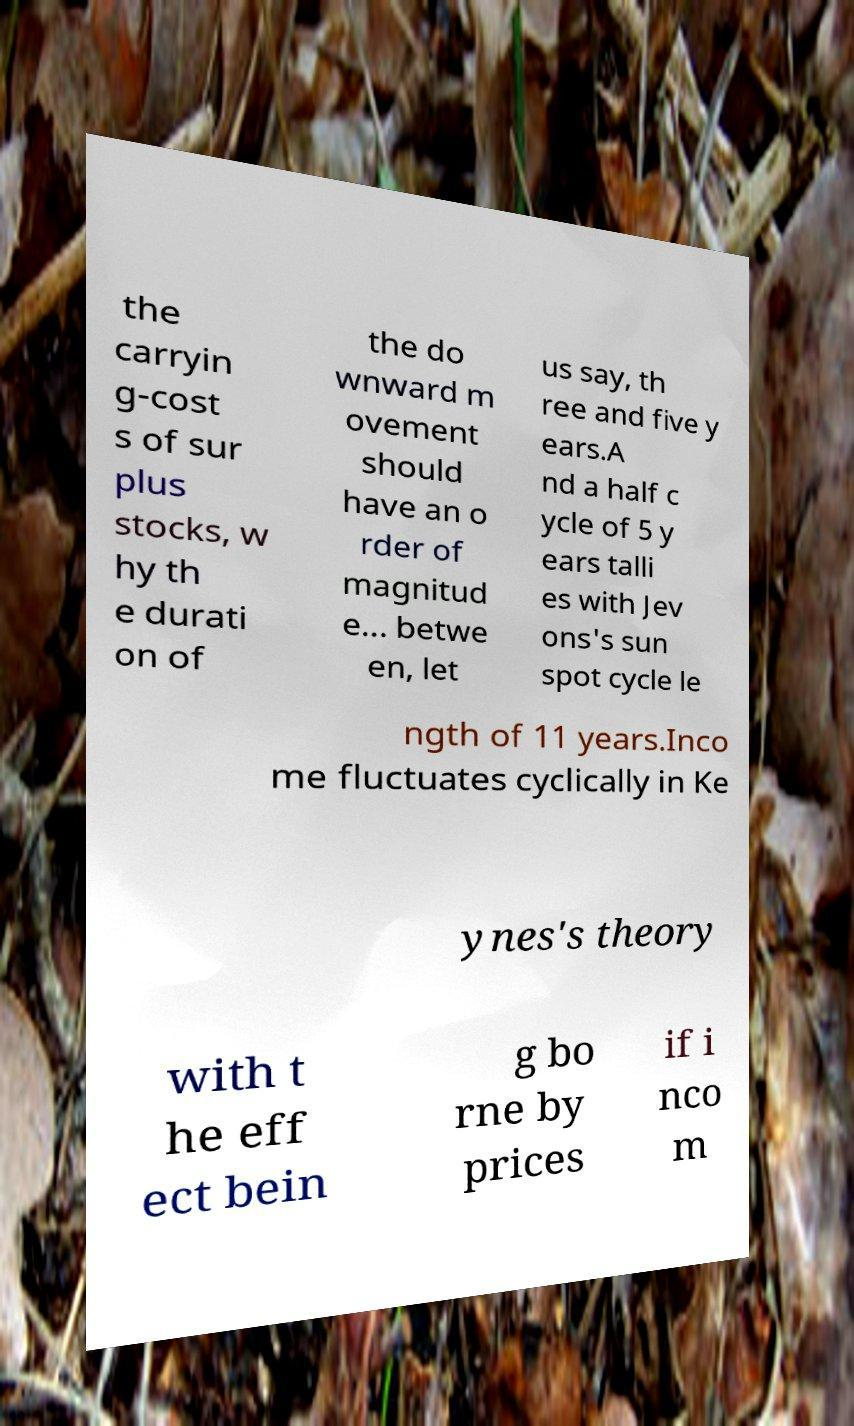For documentation purposes, I need the text within this image transcribed. Could you provide that? the carryin g-cost s of sur plus stocks, w hy th e durati on of the do wnward m ovement should have an o rder of magnitud e... betwe en, let us say, th ree and five y ears.A nd a half c ycle of 5 y ears talli es with Jev ons's sun spot cycle le ngth of 11 years.Inco me fluctuates cyclically in Ke ynes's theory with t he eff ect bein g bo rne by prices if i nco m 